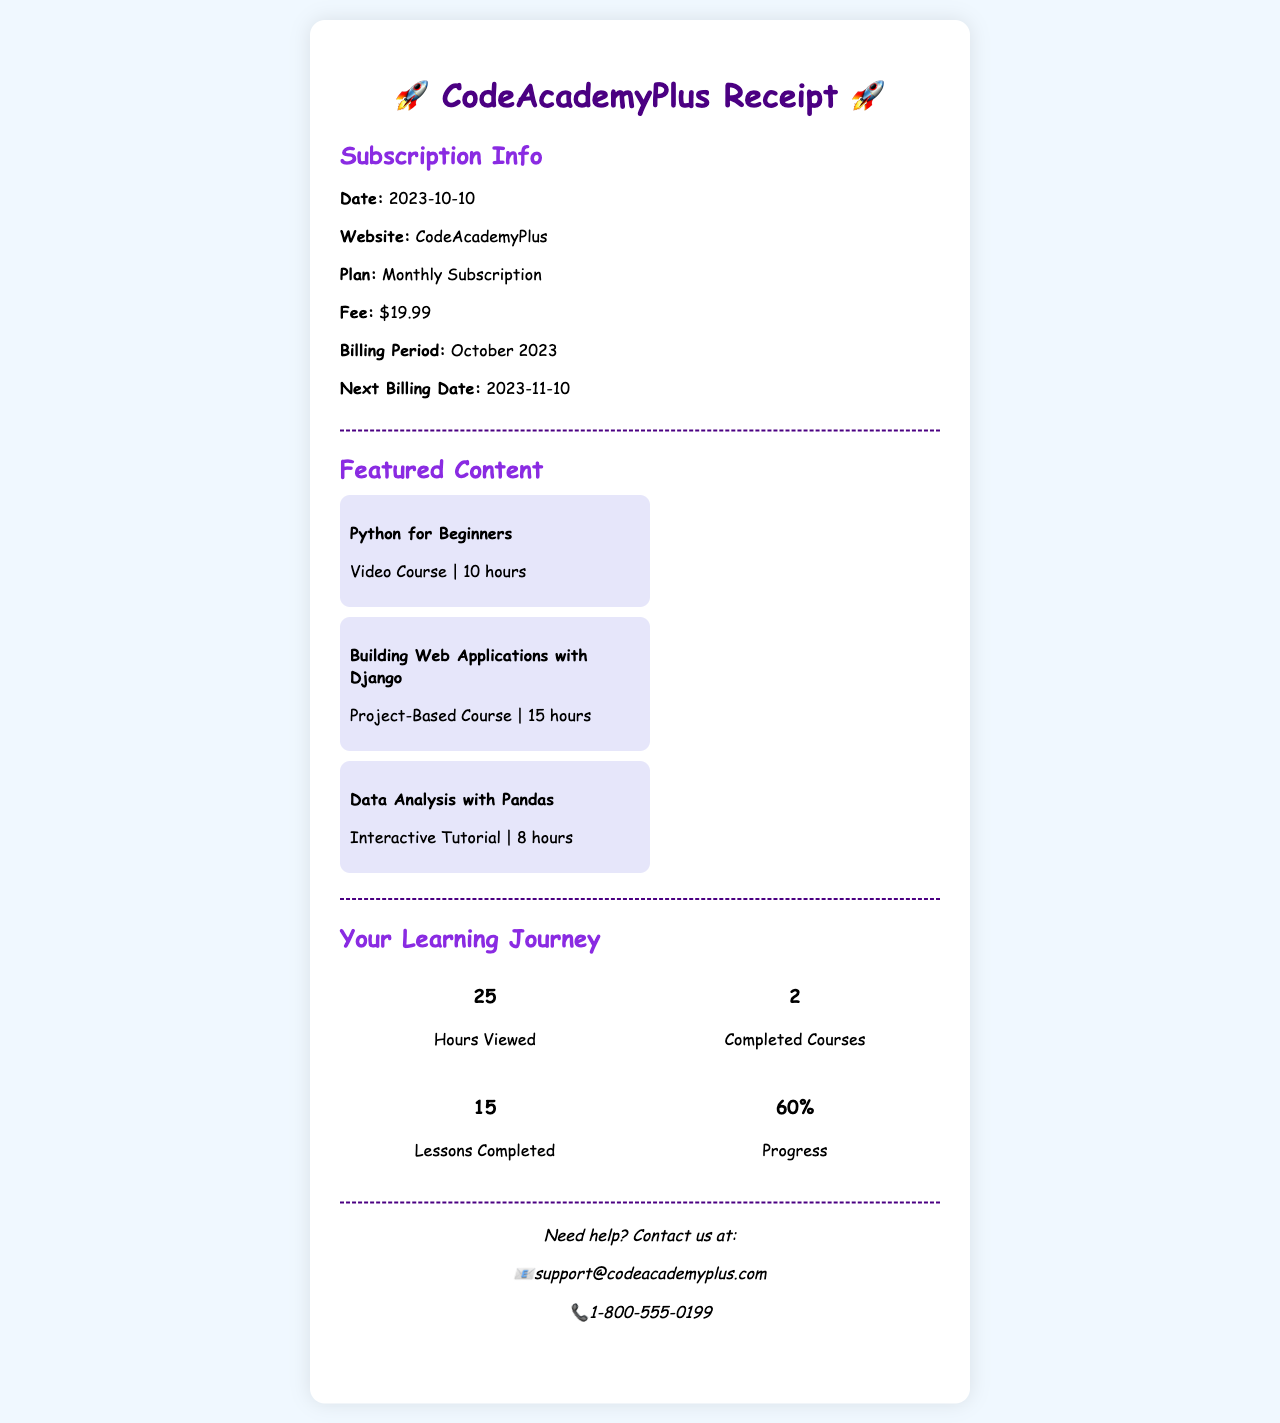What is the subscription fee? The subscription fee is specified in the document under Subscription Info.
Answer: $19.99 When was the last billing date? The last billing date can be inferred from the current billing period mentioned in the Subscription Info.
Answer: 2023-10-10 How many hours of content does "Python for Beginners" provide? The duration of "Python for Beginners" is mentioned in the Featured Content section.
Answer: 10 hours What is the progress percentage indicated in the document? Progress is summarized in the Your Learning Journey section.
Answer: 60% How many completed courses does the user have? The number of completed courses is listed in the Your Learning Journey section.
Answer: 2 What is the next billing date? The next billing date is provided in the Subscription Info section.
Answer: 2023-11-10 What type of course is "Building Web Applications with Django"? The type of course is described in the Featured Content section.
Answer: Project-Based Course How many hours have been viewed in total? The total hours viewed are specified in the Your Learning Journey section.
Answer: 25 What contact email is provided for support? The support email is found in the contact information at the bottom of the receipt.
Answer: support@codeacademyplus.com 